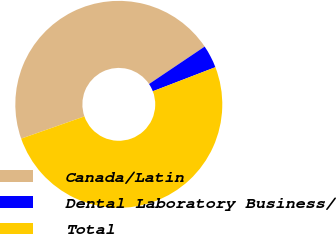Convert chart. <chart><loc_0><loc_0><loc_500><loc_500><pie_chart><fcel>Canada/Latin<fcel>Dental Laboratory Business/<fcel>Total<nl><fcel>45.95%<fcel>3.58%<fcel>50.47%<nl></chart> 